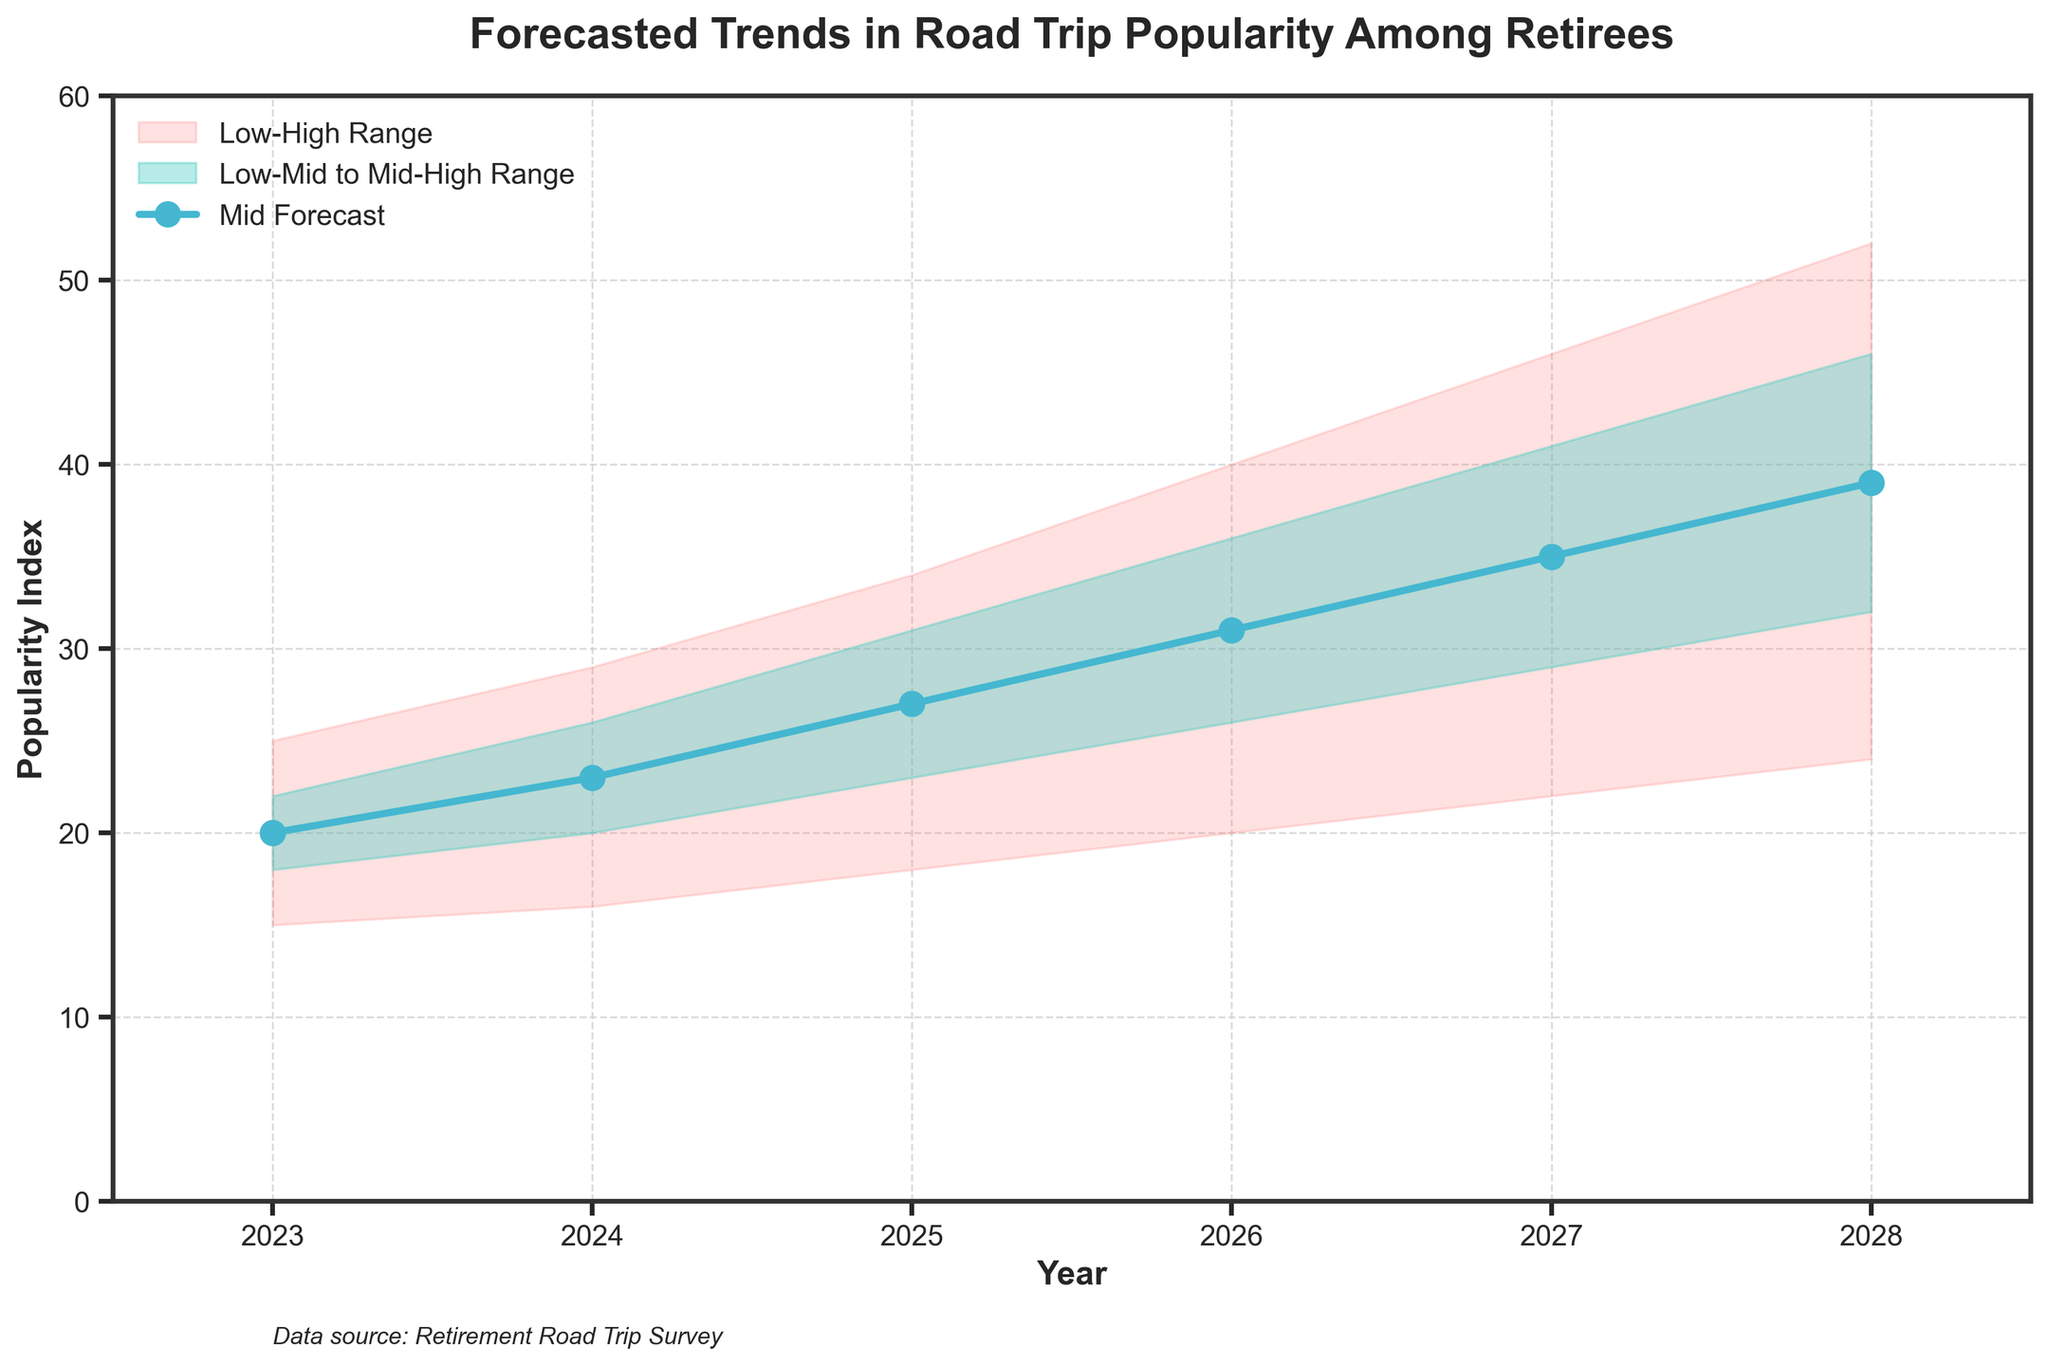what is the title of the figure? The title is mentioned at the top of the figure.
Answer: Forecasted Trends in Road Trip Popularity Among Retirees How many years are shown in the chart? Count the number of data points along the x-axis.
Answer: 6 What does the color red represent on the chart? The legend on the chart indicates what each color represents.
Answer: Low-High Range What is the mid forecast value for 2027? Locate the year 2027 on the x-axis and find the corresponding value on the Mid line, color-coded with blue.
Answer: 35 How does the forecasted popularity index change from 2023 to 2025 for the mid forecast? Compare the mid forecast values for 2023 and 2025 and calculate the difference.
Answer: It increases from 20 to 27 Which year has the highest high forecast value? Locate the highest point on the High line and identify the corresponding year on the x-axis.
Answer: 2028 What is the range of the popularity index for the year 2026? Find the difference between the High and Low values for 2026.
Answer: 40 - 20 = 20 How much does the low-mid forecast value increase from 2023 to 2028? Subtract the Low-Mid value in 2023 from the Low-Mid value in 2028.
Answer: 32 - 18 = 14 Is there an increasing trend in the mid forecast values from 2023 to 2028? Check if the mid forecast values increase each year from 2023 through 2028.
Answer: Yes What is the predicted mid-high forecast value in 2024? Locate the year 2024 on the x-axis and find the corresponding value on the Mid-High line.
Answer: 26 